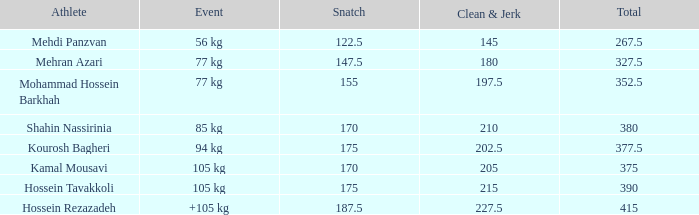How many snatches were there with a total of 267.5? 0.0. 